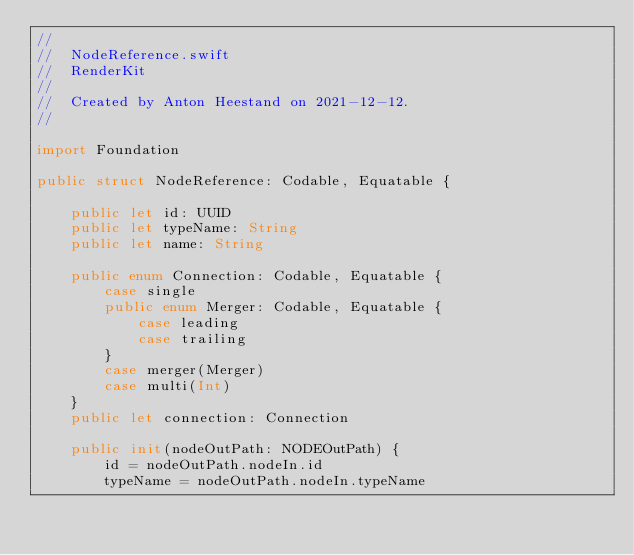<code> <loc_0><loc_0><loc_500><loc_500><_Swift_>//
//  NodeReference.swift
//  RenderKit
//
//  Created by Anton Heestand on 2021-12-12.
//

import Foundation

public struct NodeReference: Codable, Equatable {
    
    public let id: UUID
    public let typeName: String
    public let name: String
    
    public enum Connection: Codable, Equatable {
        case single
        public enum Merger: Codable, Equatable {
            case leading
            case trailing
        }
        case merger(Merger)
        case multi(Int)
    }
    public let connection: Connection
    
    public init(nodeOutPath: NODEOutPath) {
        id = nodeOutPath.nodeIn.id
        typeName = nodeOutPath.nodeIn.typeName</code> 